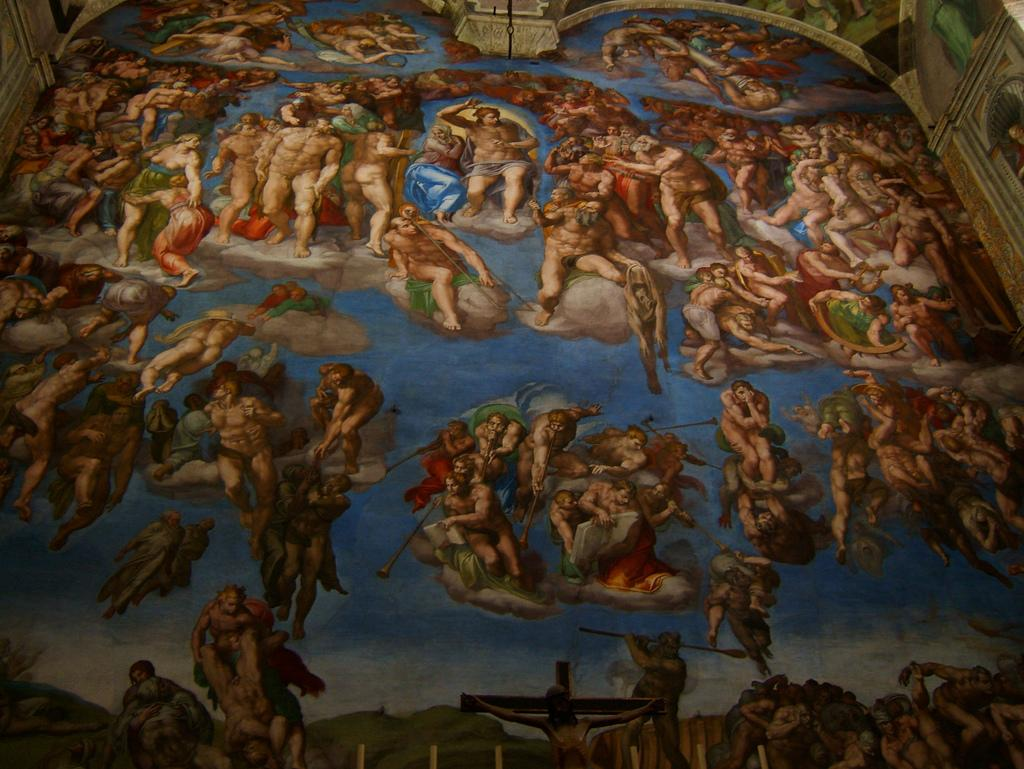What is the main subject of the image? There is a painting in the image. What does the painting depict? The painting depicts people. Where is the painting located? The painting is on the side of a building. How many cakes are being served in the lunchroom in the image? There is no lunchroom or cakes present in the image; it features a painting of people on the side of a building. 